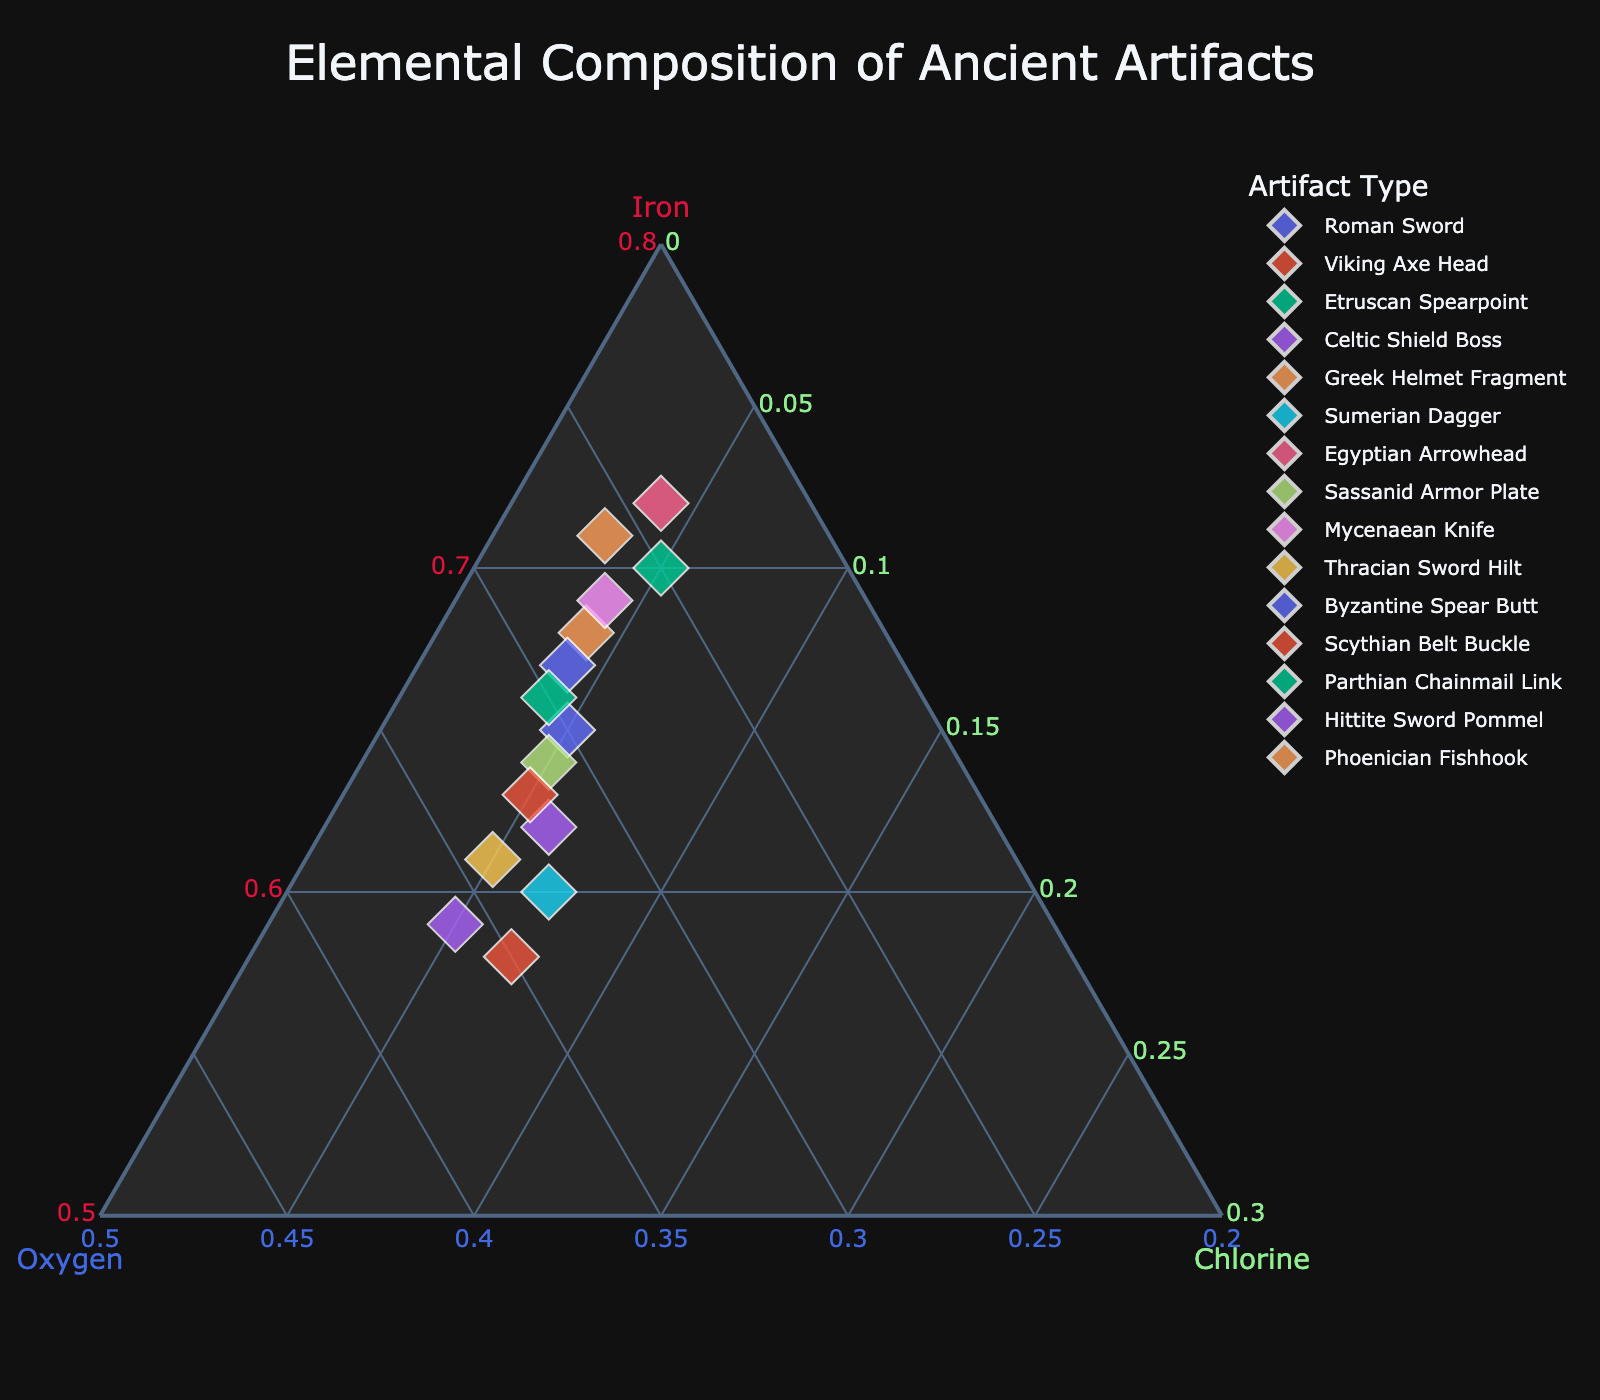How many artifacts are represented in the plot? Count the number of unique artifacts shown in the legend or the markers on the plot.
Answer: 15 What is the range of the oxygen percentages shown on the plot? Identify the minimum and maximum oxygen percentages from the axis labels: ranging from at least 24% to 36%.
Answer: 24% to 36% Which artifact has the highest iron content? Locate the data point closest to the Iron axis corner (point 'A' or 'Iron_norm'): Egyptian Arrowhead (72% iron).
Answer: Egyptian Arrowhead Which artifact has the highest chlorine percentage? Locate the data point closest to the Chlorine axis corner (point 'C' or 'Chlorine_norm'): Phoenician Fishhook (with chlorine at 3%).
Answer: Phoenician Fishhook What is the average chlorine content among all artifacts? Sum all chlorine percentages and divide by the total number of artifacts: (5+7+5+6+4+7+4+5+4+5+4+5+4+5+3)/15 = 80/15 ≈ 5.33%.
Answer: 5.33% Which artifact has a higher percentage of oxygen, the Viking Axe Head or the Hittite Sword Pommel? Compare the oxygen values: Viking Axe Head (35%) and Hittite Sword Pommel (36%). Hittite Sword Pommel has 1% higher.
Answer: Hittite Sword Pommel What is the sum of the elemental percentages for the Greek Helmet Fragment? Add the percentage values for iron, oxygen, and chlorine in the Greek Helmet Fragment: 68% + 28% + 4% = 100%.
Answer: 100% Do any two artifacts share the exact same elemental composition? Check each artifact's normalized elemental ratios to see if any fully match another; none do.
Answer: no Which artifact has the nearest overall elemental composition to the Roman Sword? Check adjacent data points' elemental ratios and compare for the nearest fit: Byzantine Spear Butt shows a very close distribution.
Answer: Byzantine Spear Butt On average, do artifacts have more iron or oxygen? Average iron (sum of iron percentages/15: (65+58+70+62+68+60+72+64+69+61+67+63+66+59+71)/15 = 66.13%) vs. oxygen (sum of oxygen percentages/15: (30+35+25+32+28+33+24+31+27+34+29+32+30+36+26)/15 = 30.07%): Iron average is higher.
Answer: Iron 